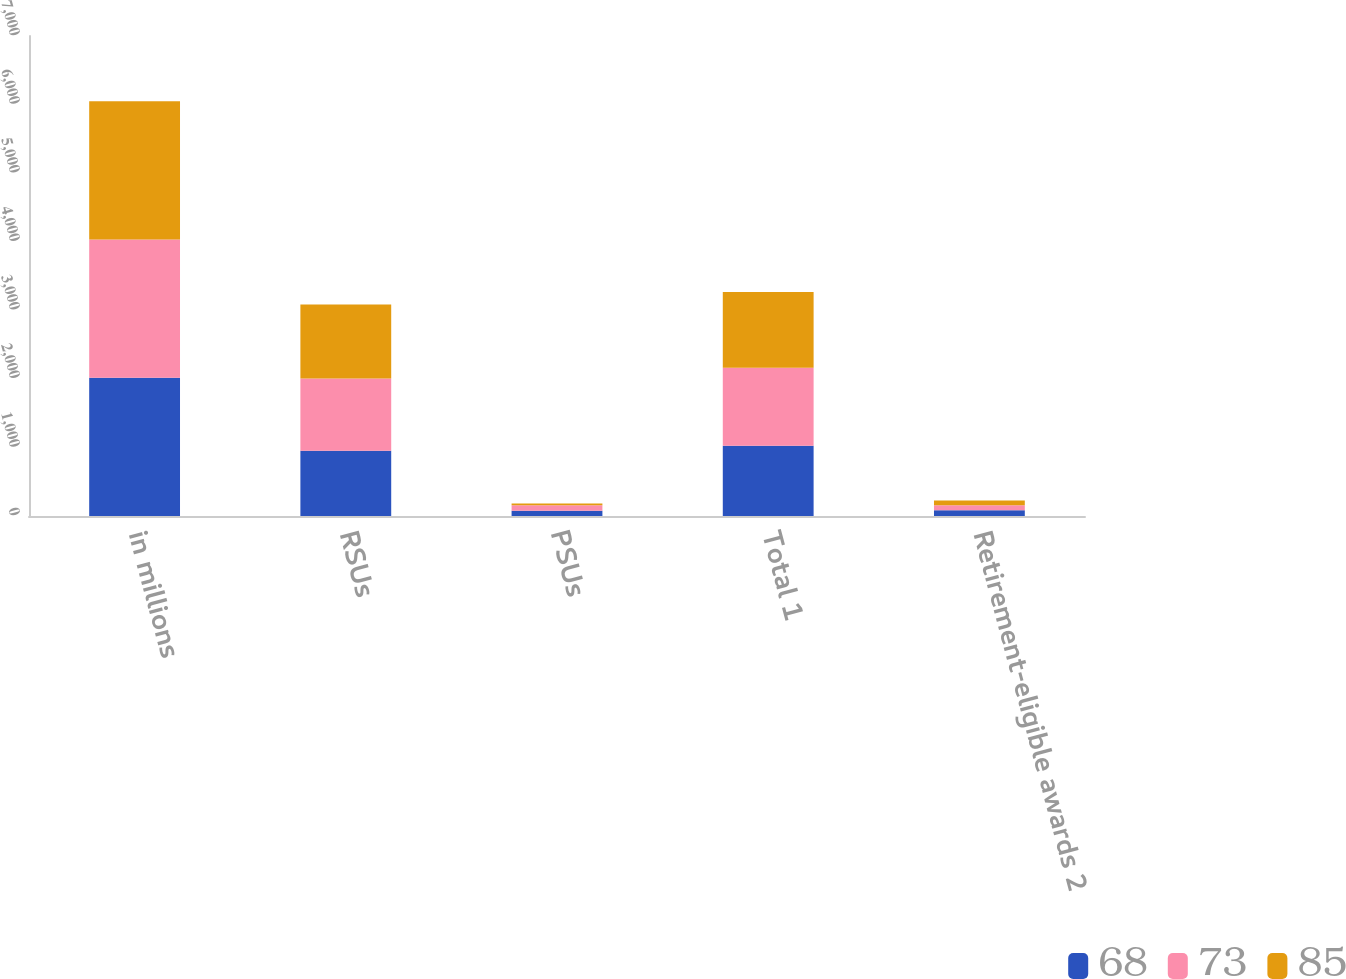<chart> <loc_0><loc_0><loc_500><loc_500><stacked_bar_chart><ecel><fcel>in millions<fcel>RSUs<fcel>PSUs<fcel>Total 1<fcel>Retirement-eligible awards 2<nl><fcel>68<fcel>2017<fcel>951<fcel>75<fcel>1026<fcel>85<nl><fcel>73<fcel>2016<fcel>1054<fcel>81<fcel>1137<fcel>73<nl><fcel>85<fcel>2015<fcel>1080<fcel>26<fcel>1103<fcel>68<nl></chart> 